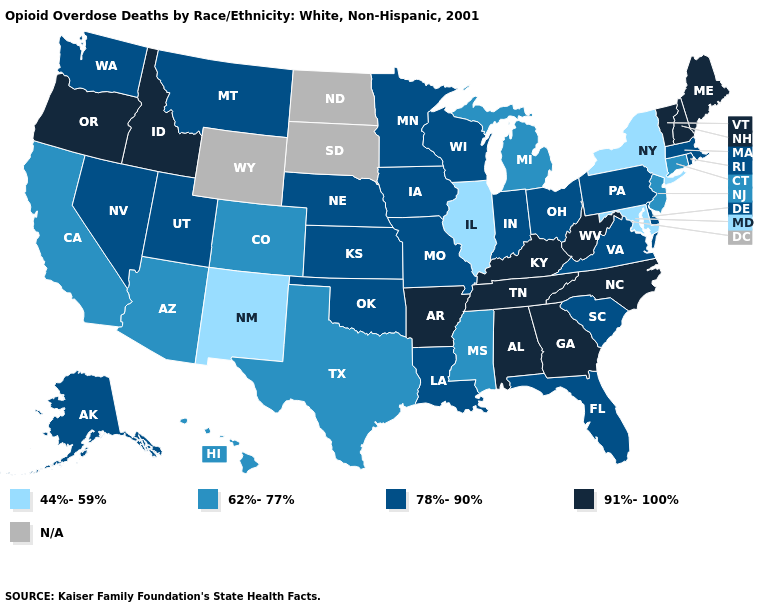Does the map have missing data?
Answer briefly. Yes. Name the states that have a value in the range 91%-100%?
Short answer required. Alabama, Arkansas, Georgia, Idaho, Kentucky, Maine, New Hampshire, North Carolina, Oregon, Tennessee, Vermont, West Virginia. What is the value of South Dakota?
Be succinct. N/A. What is the value of Illinois?
Be succinct. 44%-59%. What is the value of Rhode Island?
Quick response, please. 78%-90%. Name the states that have a value in the range 44%-59%?
Write a very short answer. Illinois, Maryland, New Mexico, New York. What is the lowest value in states that border New Mexico?
Write a very short answer. 62%-77%. What is the highest value in states that border Washington?
Short answer required. 91%-100%. Among the states that border North Carolina , does Virginia have the lowest value?
Quick response, please. Yes. What is the lowest value in the USA?
Concise answer only. 44%-59%. Name the states that have a value in the range 78%-90%?
Answer briefly. Alaska, Delaware, Florida, Indiana, Iowa, Kansas, Louisiana, Massachusetts, Minnesota, Missouri, Montana, Nebraska, Nevada, Ohio, Oklahoma, Pennsylvania, Rhode Island, South Carolina, Utah, Virginia, Washington, Wisconsin. What is the value of Rhode Island?
Write a very short answer. 78%-90%. Among the states that border Indiana , does Kentucky have the highest value?
Answer briefly. Yes. Name the states that have a value in the range 44%-59%?
Concise answer only. Illinois, Maryland, New Mexico, New York. 